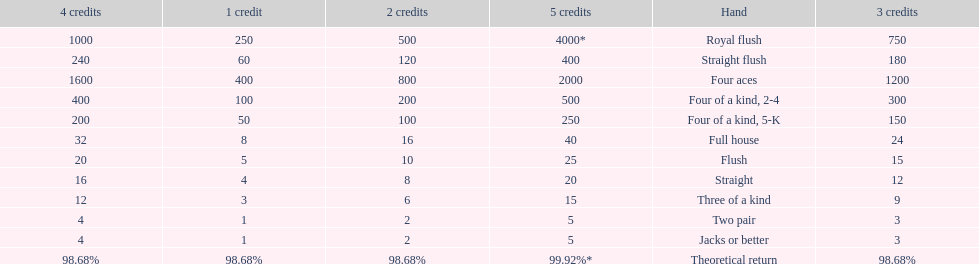Which is a higher standing hand: a straight or a flush? Flush. 